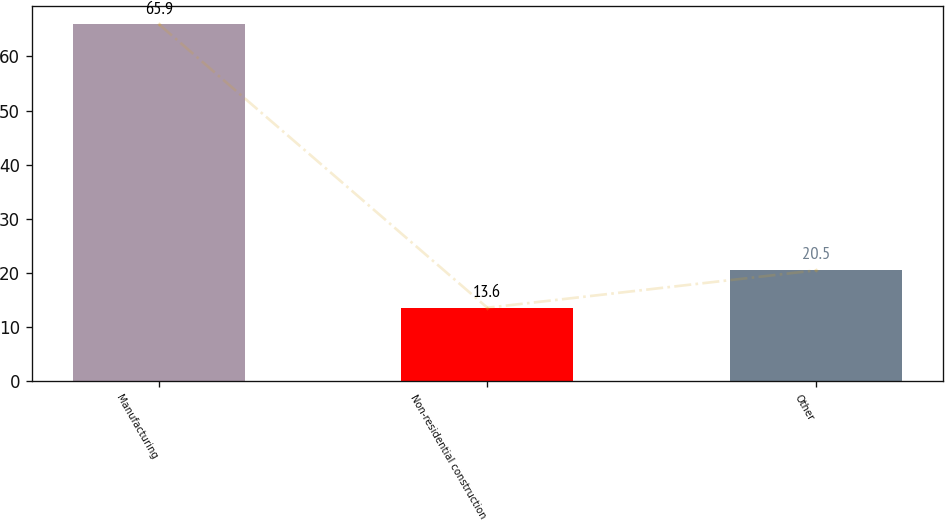<chart> <loc_0><loc_0><loc_500><loc_500><bar_chart><fcel>Manufacturing<fcel>Non-residential construction<fcel>Other<nl><fcel>65.9<fcel>13.6<fcel>20.5<nl></chart> 